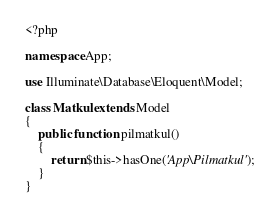Convert code to text. <code><loc_0><loc_0><loc_500><loc_500><_PHP_><?php

namespace App;

use Illuminate\Database\Eloquent\Model;

class Matkul extends Model
{
    public function pilmatkul()
    {
        return $this->hasOne('App\Pilmatkul');
    }
}
</code> 